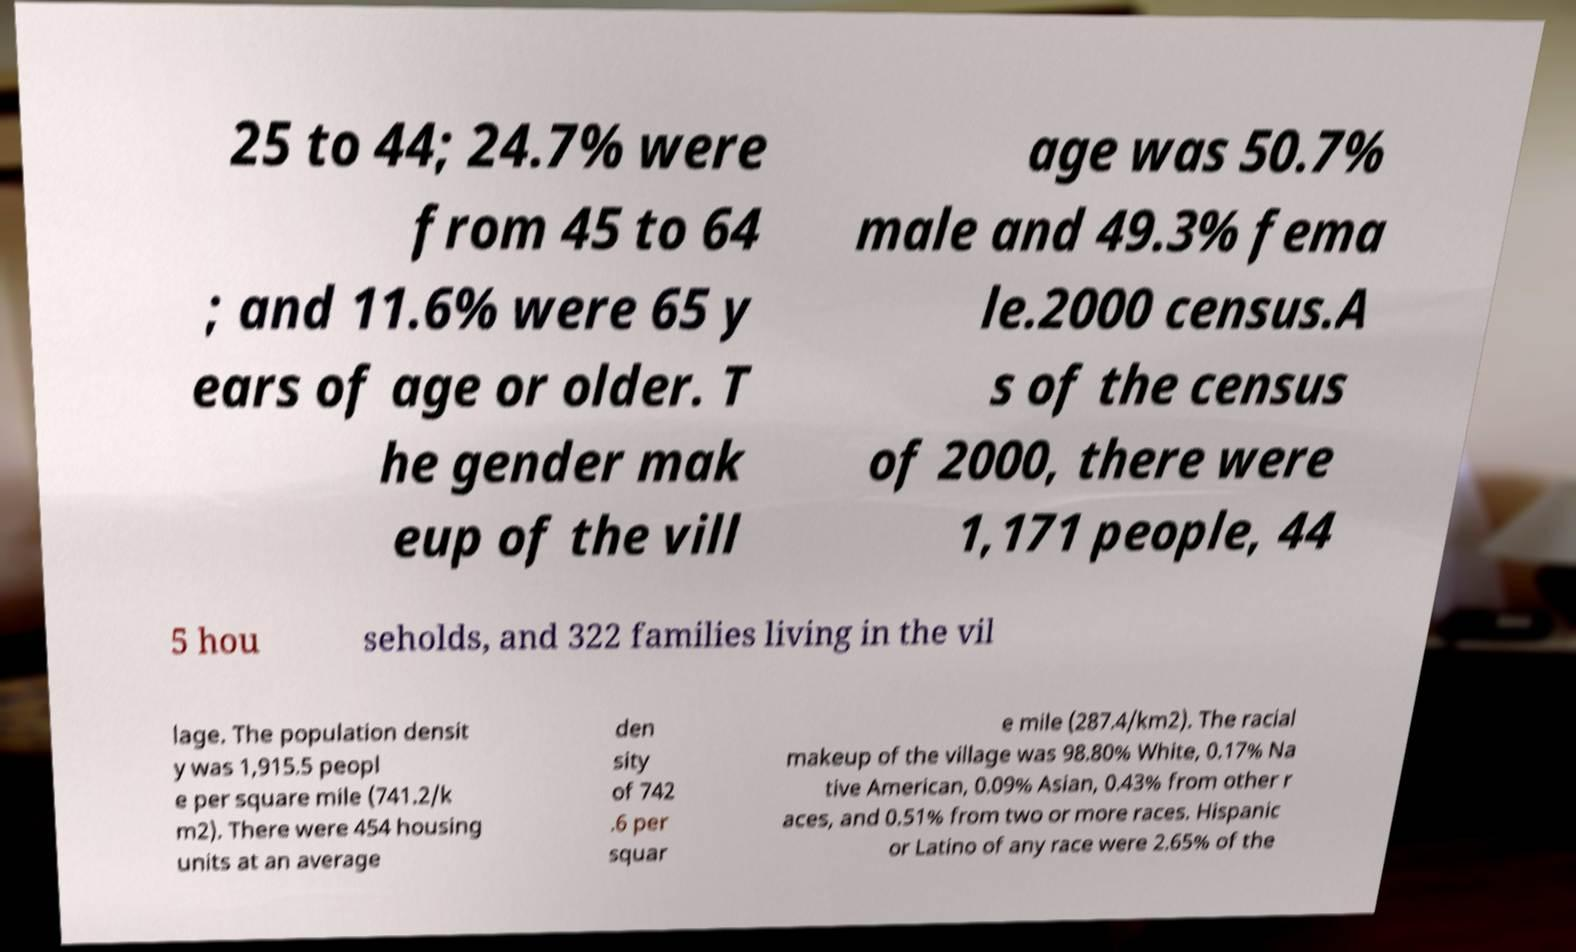I need the written content from this picture converted into text. Can you do that? 25 to 44; 24.7% were from 45 to 64 ; and 11.6% were 65 y ears of age or older. T he gender mak eup of the vill age was 50.7% male and 49.3% fema le.2000 census.A s of the census of 2000, there were 1,171 people, 44 5 hou seholds, and 322 families living in the vil lage. The population densit y was 1,915.5 peopl e per square mile (741.2/k m2). There were 454 housing units at an average den sity of 742 .6 per squar e mile (287.4/km2). The racial makeup of the village was 98.80% White, 0.17% Na tive American, 0.09% Asian, 0.43% from other r aces, and 0.51% from two or more races. Hispanic or Latino of any race were 2.65% of the 